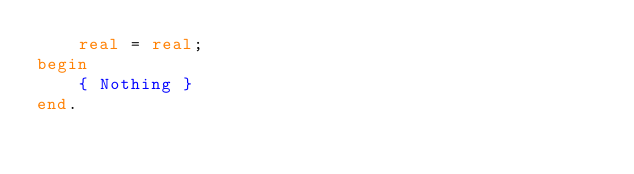Convert code to text. <code><loc_0><loc_0><loc_500><loc_500><_Pascal_>	real = real;
begin
	{ Nothing }
end.</code> 